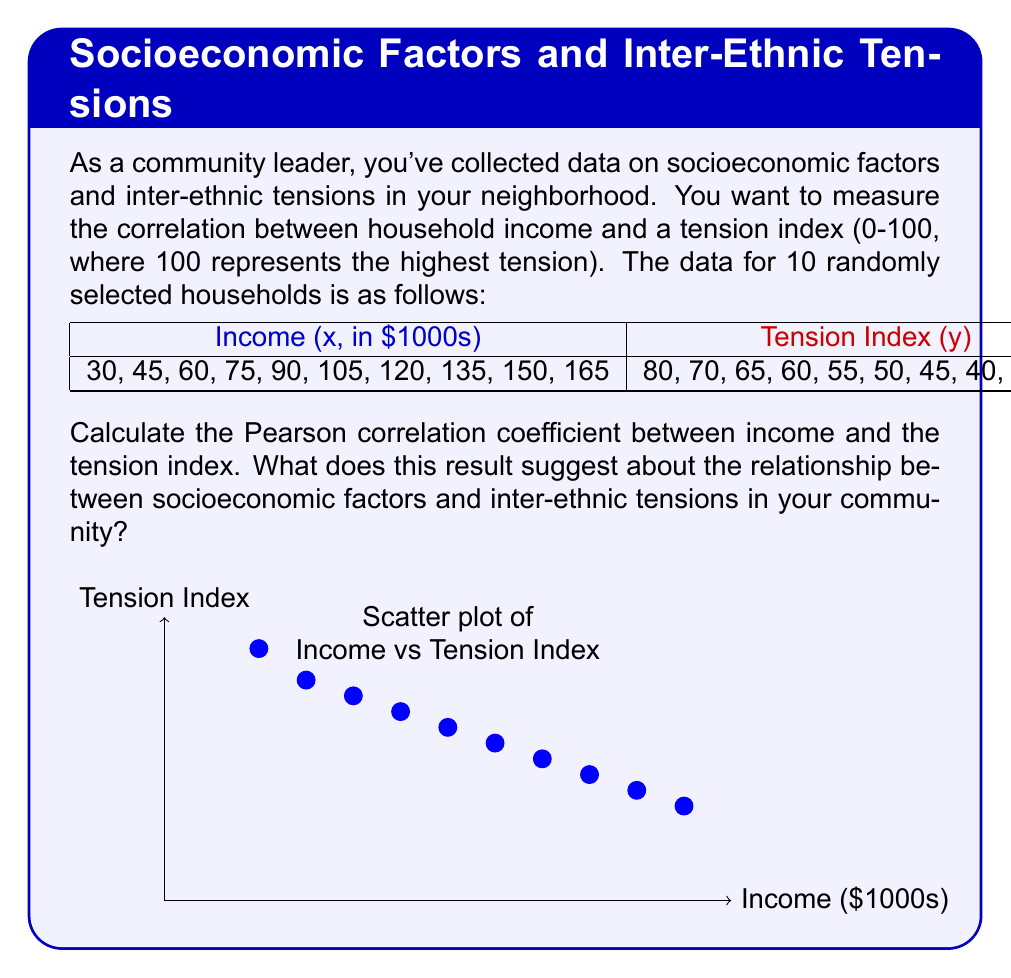Solve this math problem. To calculate the Pearson correlation coefficient (r), we'll use the formula:

$$ r = \frac{\sum_{i=1}^{n} (x_i - \bar{x})(y_i - \bar{y})}{\sqrt{\sum_{i=1}^{n} (x_i - \bar{x})^2 \sum_{i=1}^{n} (y_i - \bar{y})^2}} $$

Step 1: Calculate the means $\bar{x}$ and $\bar{y}$
$\bar{x} = \frac{30 + 45 + 60 + 75 + 90 + 105 + 120 + 135 + 150 + 165}{10} = 97.5$
$\bar{y} = \frac{80 + 70 + 65 + 60 + 55 + 50 + 45 + 40 + 35 + 30}{10} = 53$

Step 2: Calculate $(x_i - \bar{x})$, $(y_i - \bar{y})$, $(x_i - \bar{x})^2$, $(y_i - \bar{y})^2$, and $(x_i - \bar{x})(y_i - \bar{y})$ for each pair

Step 3: Sum up the values
$\sum (x_i - \bar{x})(y_i - \bar{y}) = -20625$
$\sum (x_i - \bar{x})^2 = 20625$
$\sum (y_i - \bar{y})^2 = 2050$

Step 4: Apply the formula
$$ r = \frac{-20625}{\sqrt{20625 \times 2050}} = -0.9987 $$

The Pearson correlation coefficient is approximately -0.9987, which indicates a very strong negative correlation between income and the tension index.

This result suggests that in your community, as household income increases, inter-ethnic tensions tend to decrease significantly. The relationship is almost perfectly linear and negative. This information could be valuable for developing targeted interventions to reduce tensions, focusing on economic development and income equality as potential strategies to improve inter-ethnic relations.
Answer: $r \approx -0.9987$ 